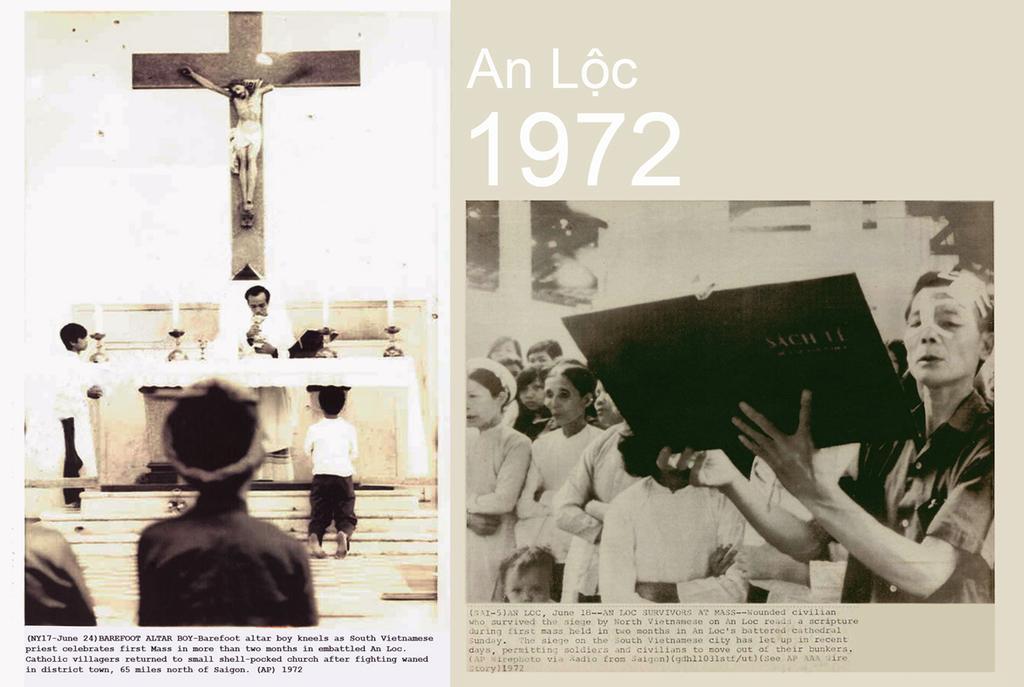How would you summarize this image in a sentence or two? In this image there is a collage picture, in that there are two black and white posters, in one there are people, behind that people there is jesus and at the bottom there is some text, in second picture there are people one person is holding a book in his hands, at the top and bottom some text is written. 